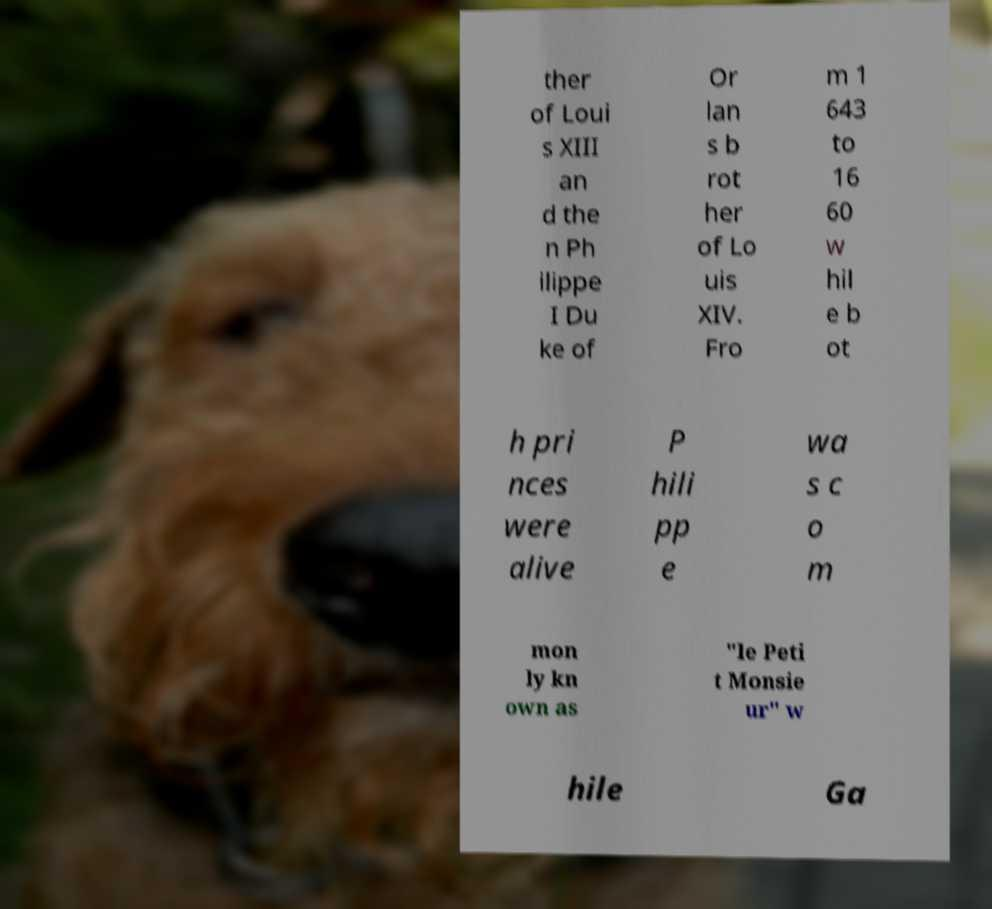There's text embedded in this image that I need extracted. Can you transcribe it verbatim? ther of Loui s XIII an d the n Ph ilippe I Du ke of Or lan s b rot her of Lo uis XIV. Fro m 1 643 to 16 60 w hil e b ot h pri nces were alive P hili pp e wa s c o m mon ly kn own as "le Peti t Monsie ur" w hile Ga 